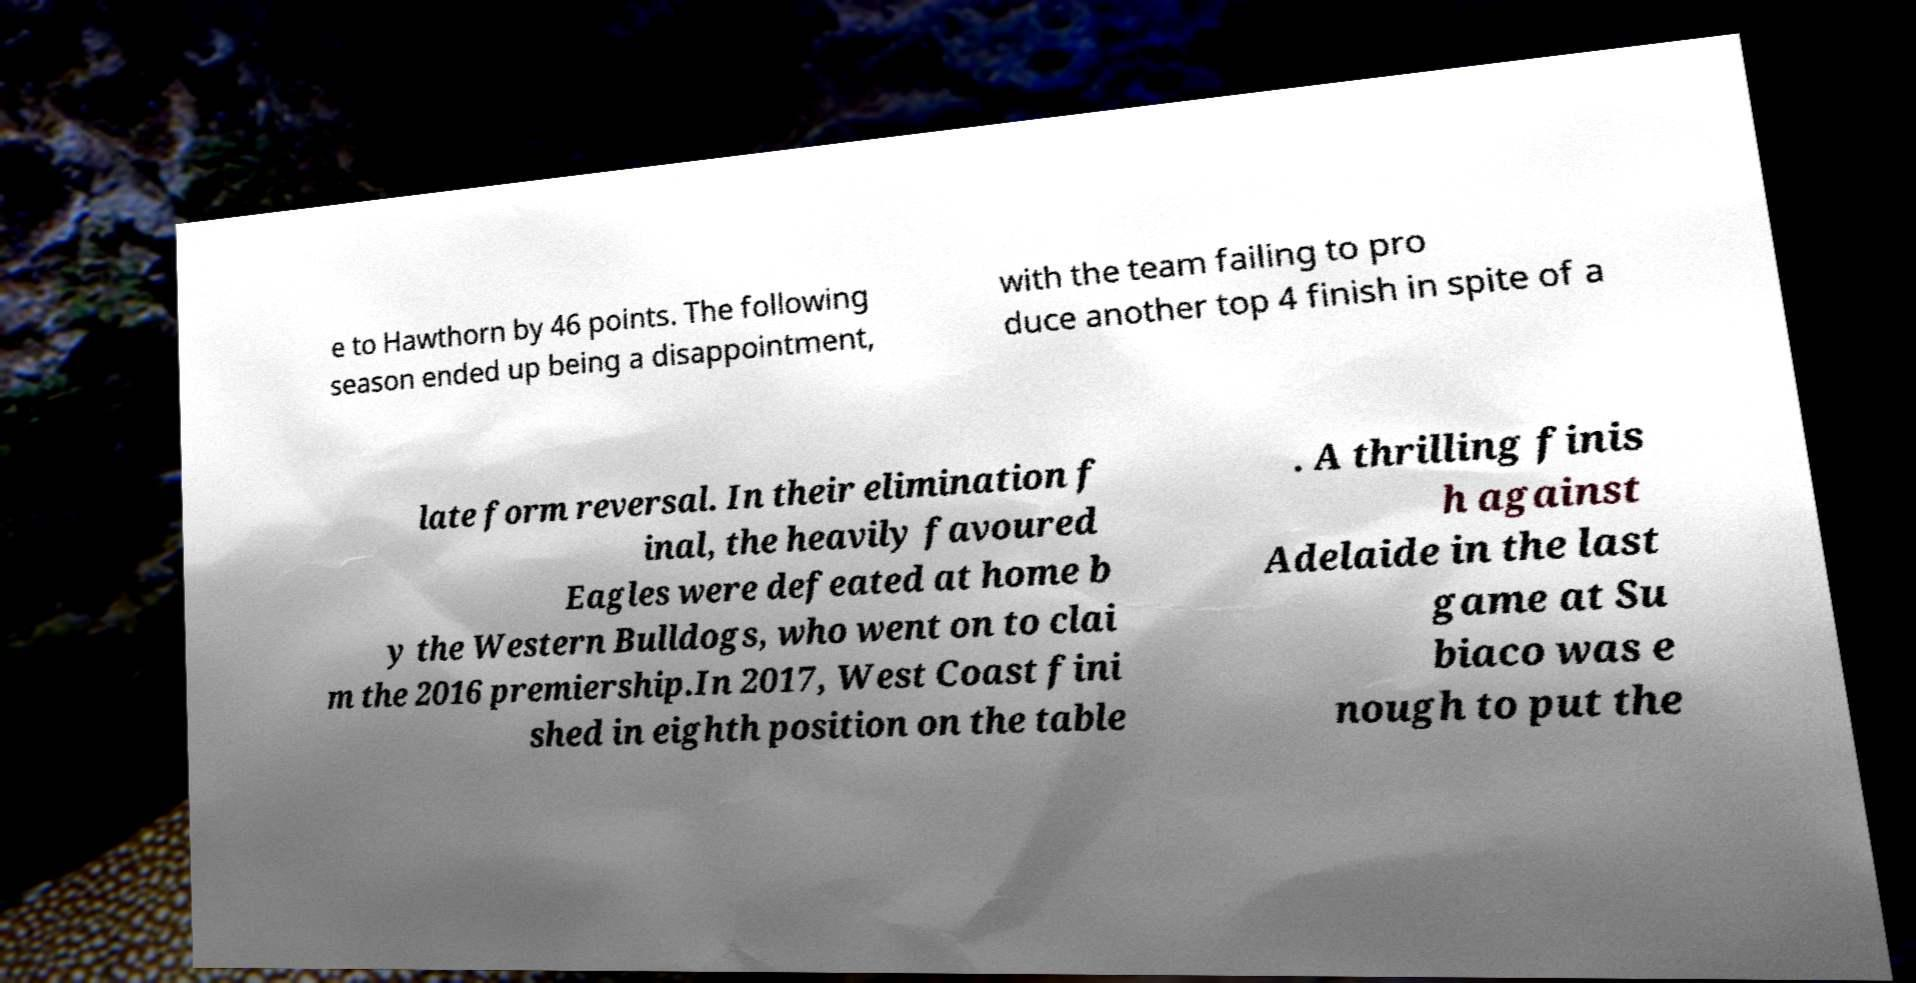Please read and relay the text visible in this image. What does it say? e to Hawthorn by 46 points. The following season ended up being a disappointment, with the team failing to pro duce another top 4 finish in spite of a late form reversal. In their elimination f inal, the heavily favoured Eagles were defeated at home b y the Western Bulldogs, who went on to clai m the 2016 premiership.In 2017, West Coast fini shed in eighth position on the table . A thrilling finis h against Adelaide in the last game at Su biaco was e nough to put the 